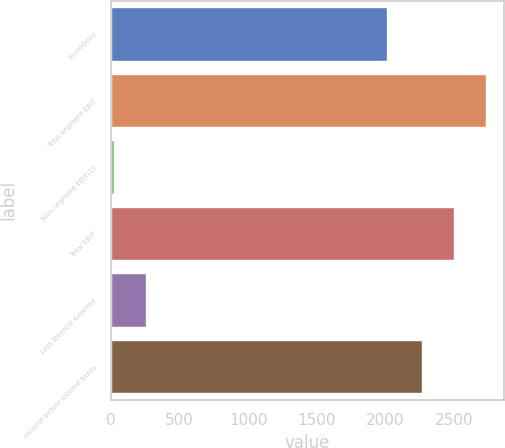Convert chart to OTSL. <chart><loc_0><loc_0><loc_500><loc_500><bar_chart><fcel>In millions<fcel>Total segment EBIT<fcel>Non-segment EBIT(1)<fcel>Total EBIT<fcel>Less Interest expense<fcel>Income before income taxes<nl><fcel>2012<fcel>2731.6<fcel>25<fcel>2501.3<fcel>255.3<fcel>2271<nl></chart> 